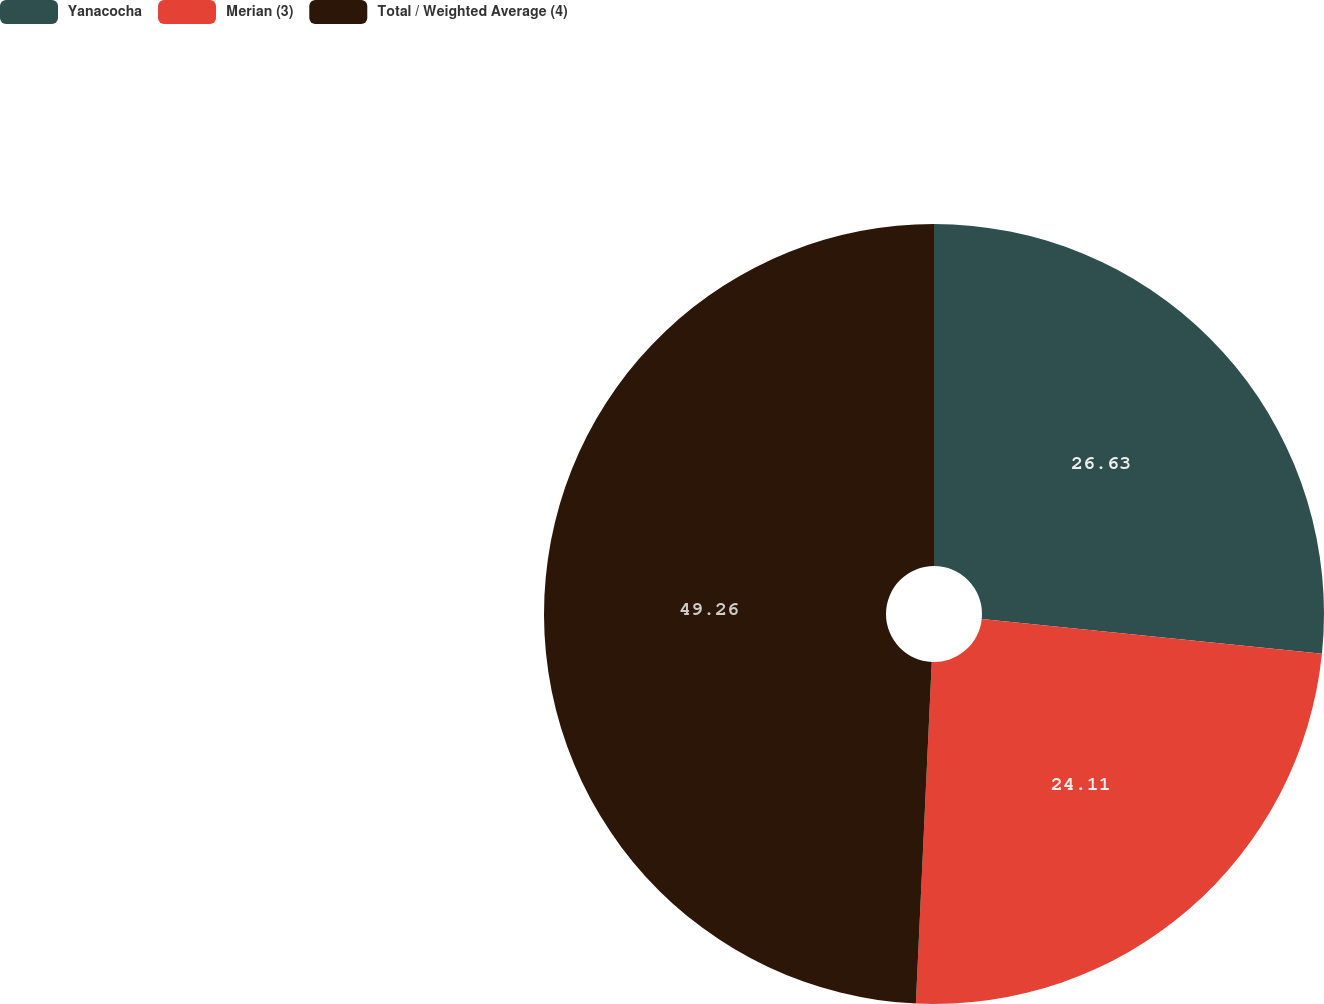Convert chart to OTSL. <chart><loc_0><loc_0><loc_500><loc_500><pie_chart><fcel>Yanacocha<fcel>Merian (3)<fcel>Total / Weighted Average (4)<nl><fcel>26.63%<fcel>24.11%<fcel>49.26%<nl></chart> 